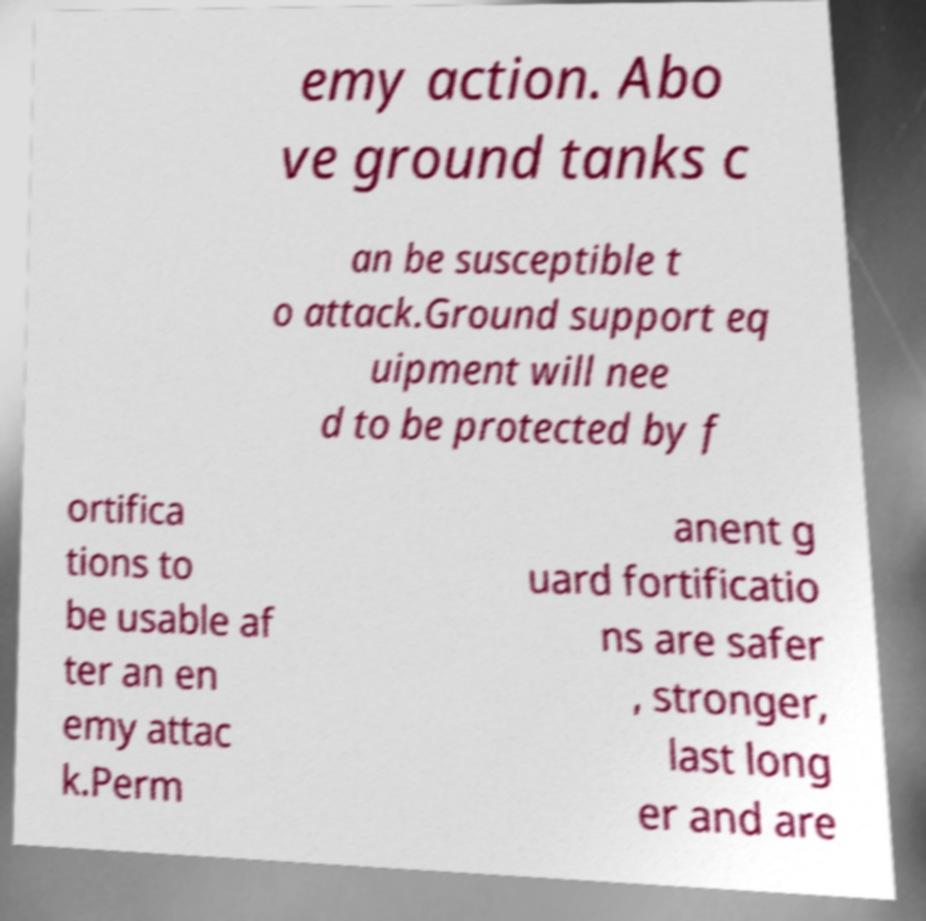Please read and relay the text visible in this image. What does it say? emy action. Abo ve ground tanks c an be susceptible t o attack.Ground support eq uipment will nee d to be protected by f ortifica tions to be usable af ter an en emy attac k.Perm anent g uard fortificatio ns are safer , stronger, last long er and are 